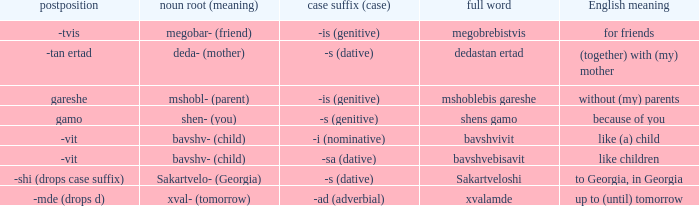What is English Meaning, when Full Word is "Shens Gamo"? Because of you. 